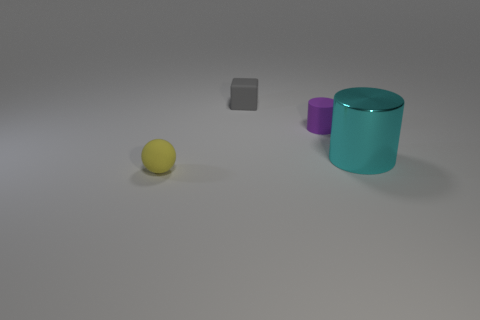If this image were part of a larger series, what do you imagine the next image might contain? If this image were part of a series, the next one might introduce a new element for contrast or comparison, such as a larger object to emphasize the scale, or an item with a vivid color to make the pastel shades pop, or even introduce a human element to interact with the objects. 